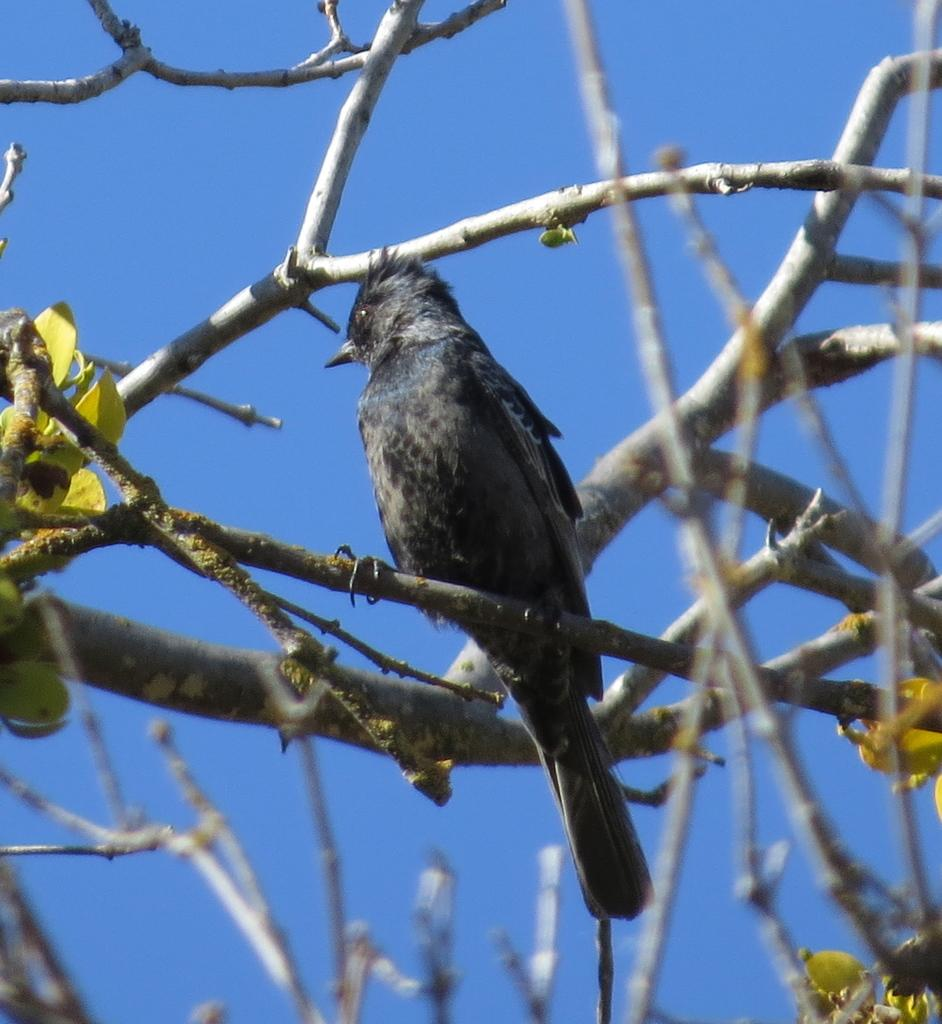What type of animal can be seen in the image? There is a bird in the image. Where is the bird located? The bird is on a branch. What can be seen in the image besides the bird? There are leaves and stems visible in the image. What is visible in the background of the image? The sky is visible in the background of the image. How many legs can be seen on the pot in the image? There is no pot present in the image, so it is not possible to determine the number of legs on a pot. 